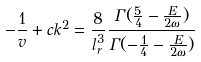<formula> <loc_0><loc_0><loc_500><loc_500>- \frac { 1 } { v } + c k ^ { 2 } = \frac { 8 } { l _ { r } ^ { 3 } } \frac { \Gamma ( \frac { 5 } { 4 } - \frac { E } { 2 \omega } ) } { \Gamma ( - \frac { 1 } { 4 } - \frac { E } { 2 \omega } ) }</formula> 